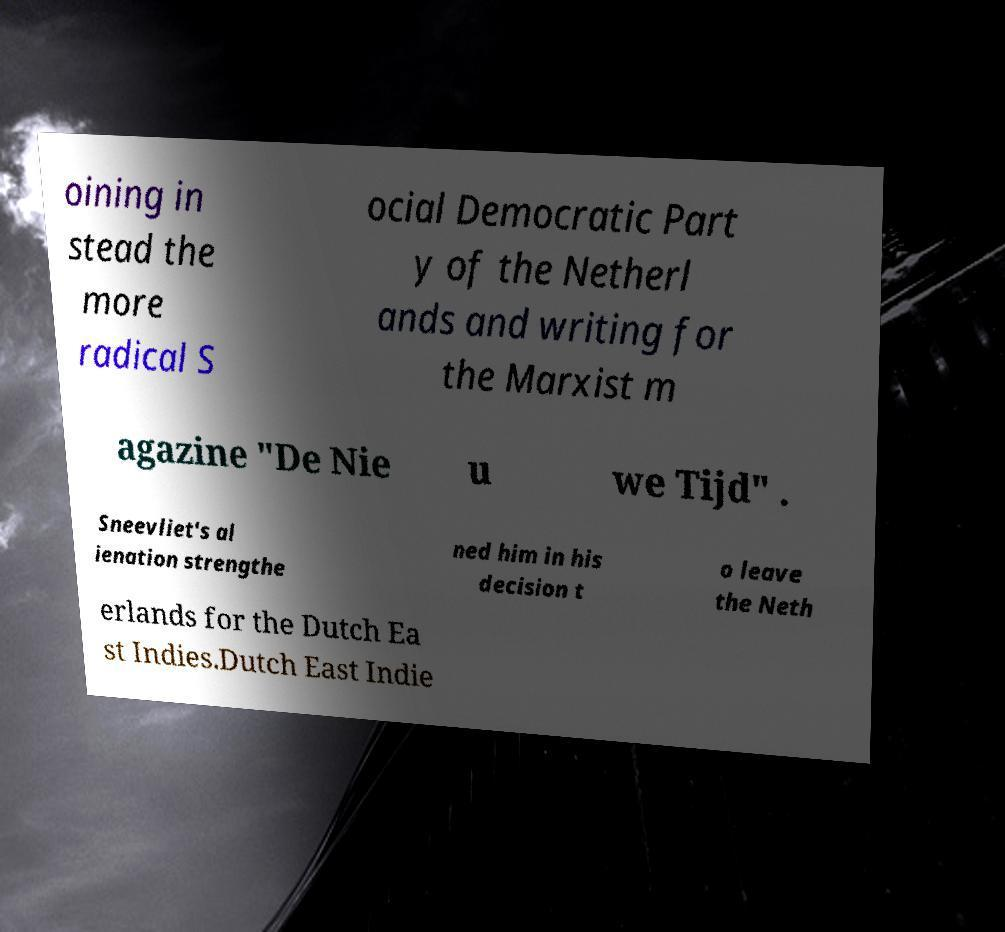Please identify and transcribe the text found in this image. oining in stead the more radical S ocial Democratic Part y of the Netherl ands and writing for the Marxist m agazine "De Nie u we Tijd" . Sneevliet's al ienation strengthe ned him in his decision t o leave the Neth erlands for the Dutch Ea st Indies.Dutch East Indie 